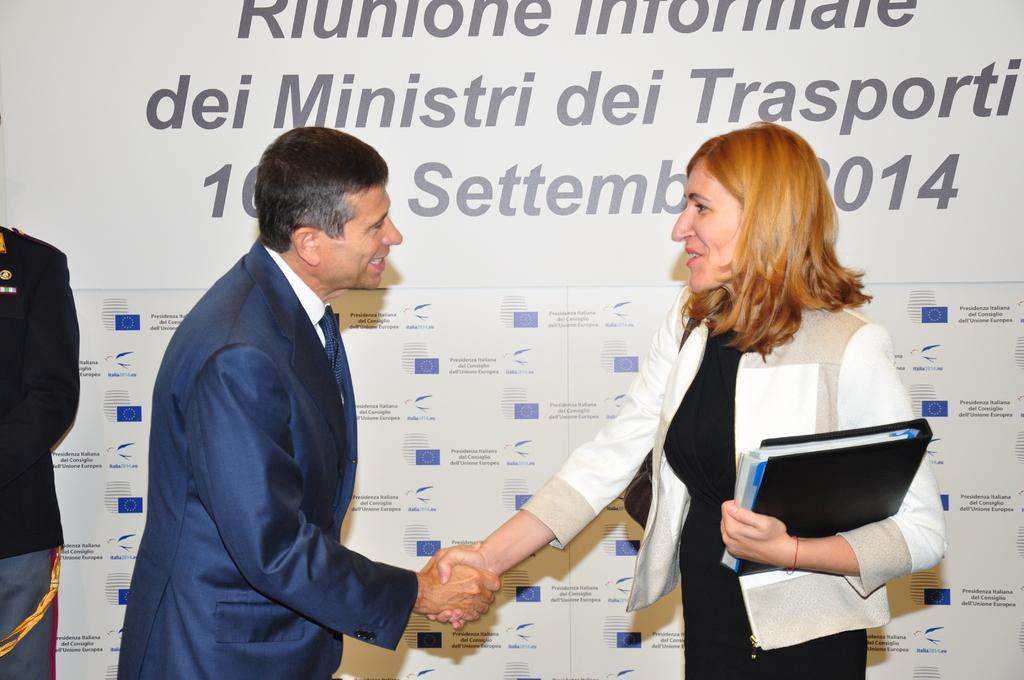In one or two sentences, can you explain what this image depicts? In the image there are two people greeting each other and the woman is wearing a bag and also holding some files in the hand and behind them there is a banner and on the left side another person is standing and he is partially visible. 